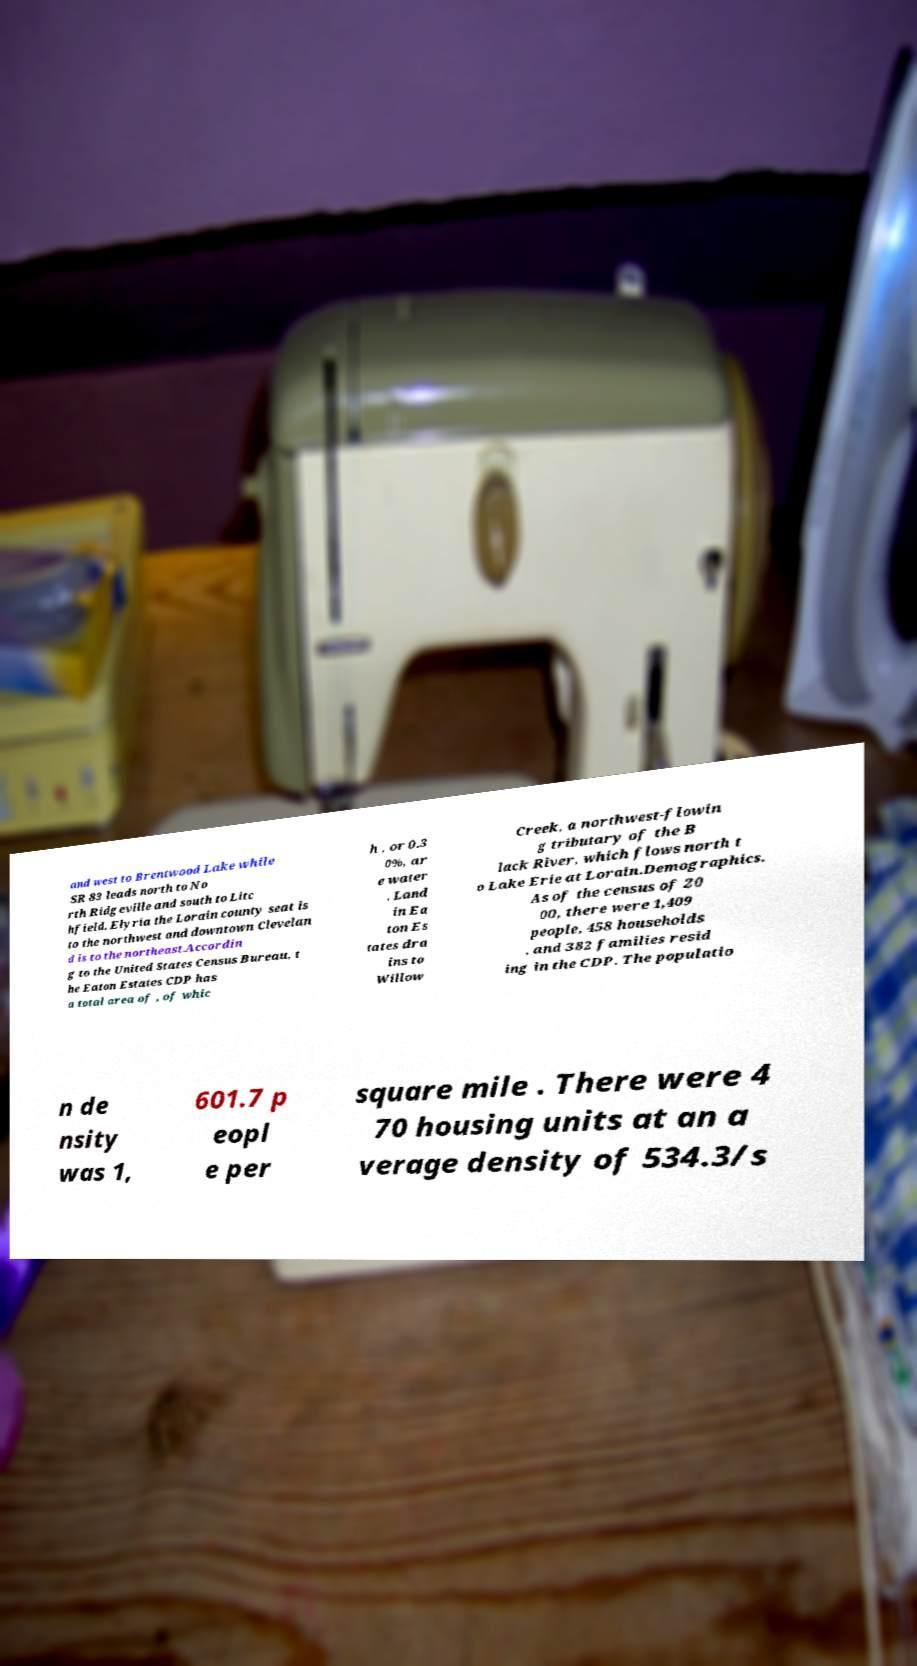Can you accurately transcribe the text from the provided image for me? and west to Brentwood Lake while SR 83 leads north to No rth Ridgeville and south to Litc hfield. Elyria the Lorain county seat is to the northwest and downtown Clevelan d is to the northeast.Accordin g to the United States Census Bureau, t he Eaton Estates CDP has a total area of , of whic h , or 0.3 0%, ar e water . Land in Ea ton Es tates dra ins to Willow Creek, a northwest-flowin g tributary of the B lack River, which flows north t o Lake Erie at Lorain.Demographics. As of the census of 20 00, there were 1,409 people, 458 households , and 382 families resid ing in the CDP. The populatio n de nsity was 1, 601.7 p eopl e per square mile . There were 4 70 housing units at an a verage density of 534.3/s 